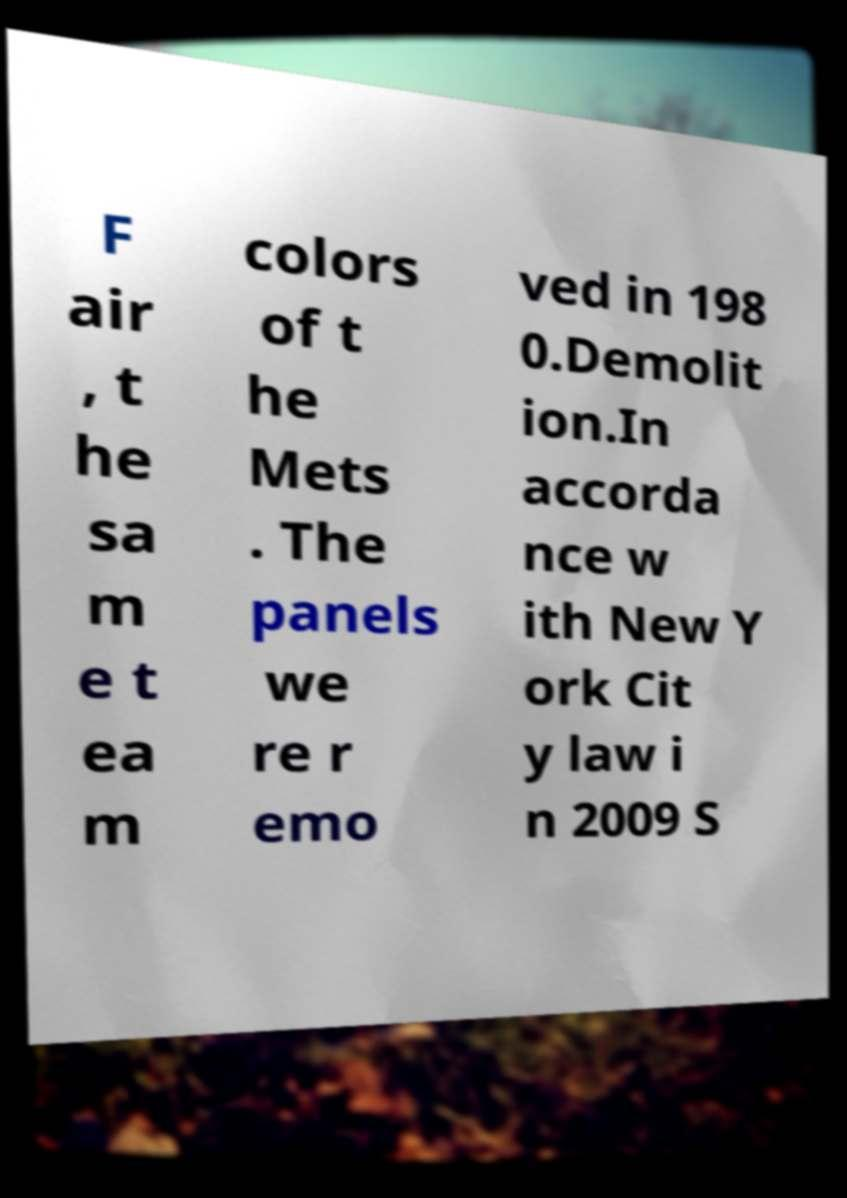Can you read and provide the text displayed in the image?This photo seems to have some interesting text. Can you extract and type it out for me? F air , t he sa m e t ea m colors of t he Mets . The panels we re r emo ved in 198 0.Demolit ion.In accorda nce w ith New Y ork Cit y law i n 2009 S 